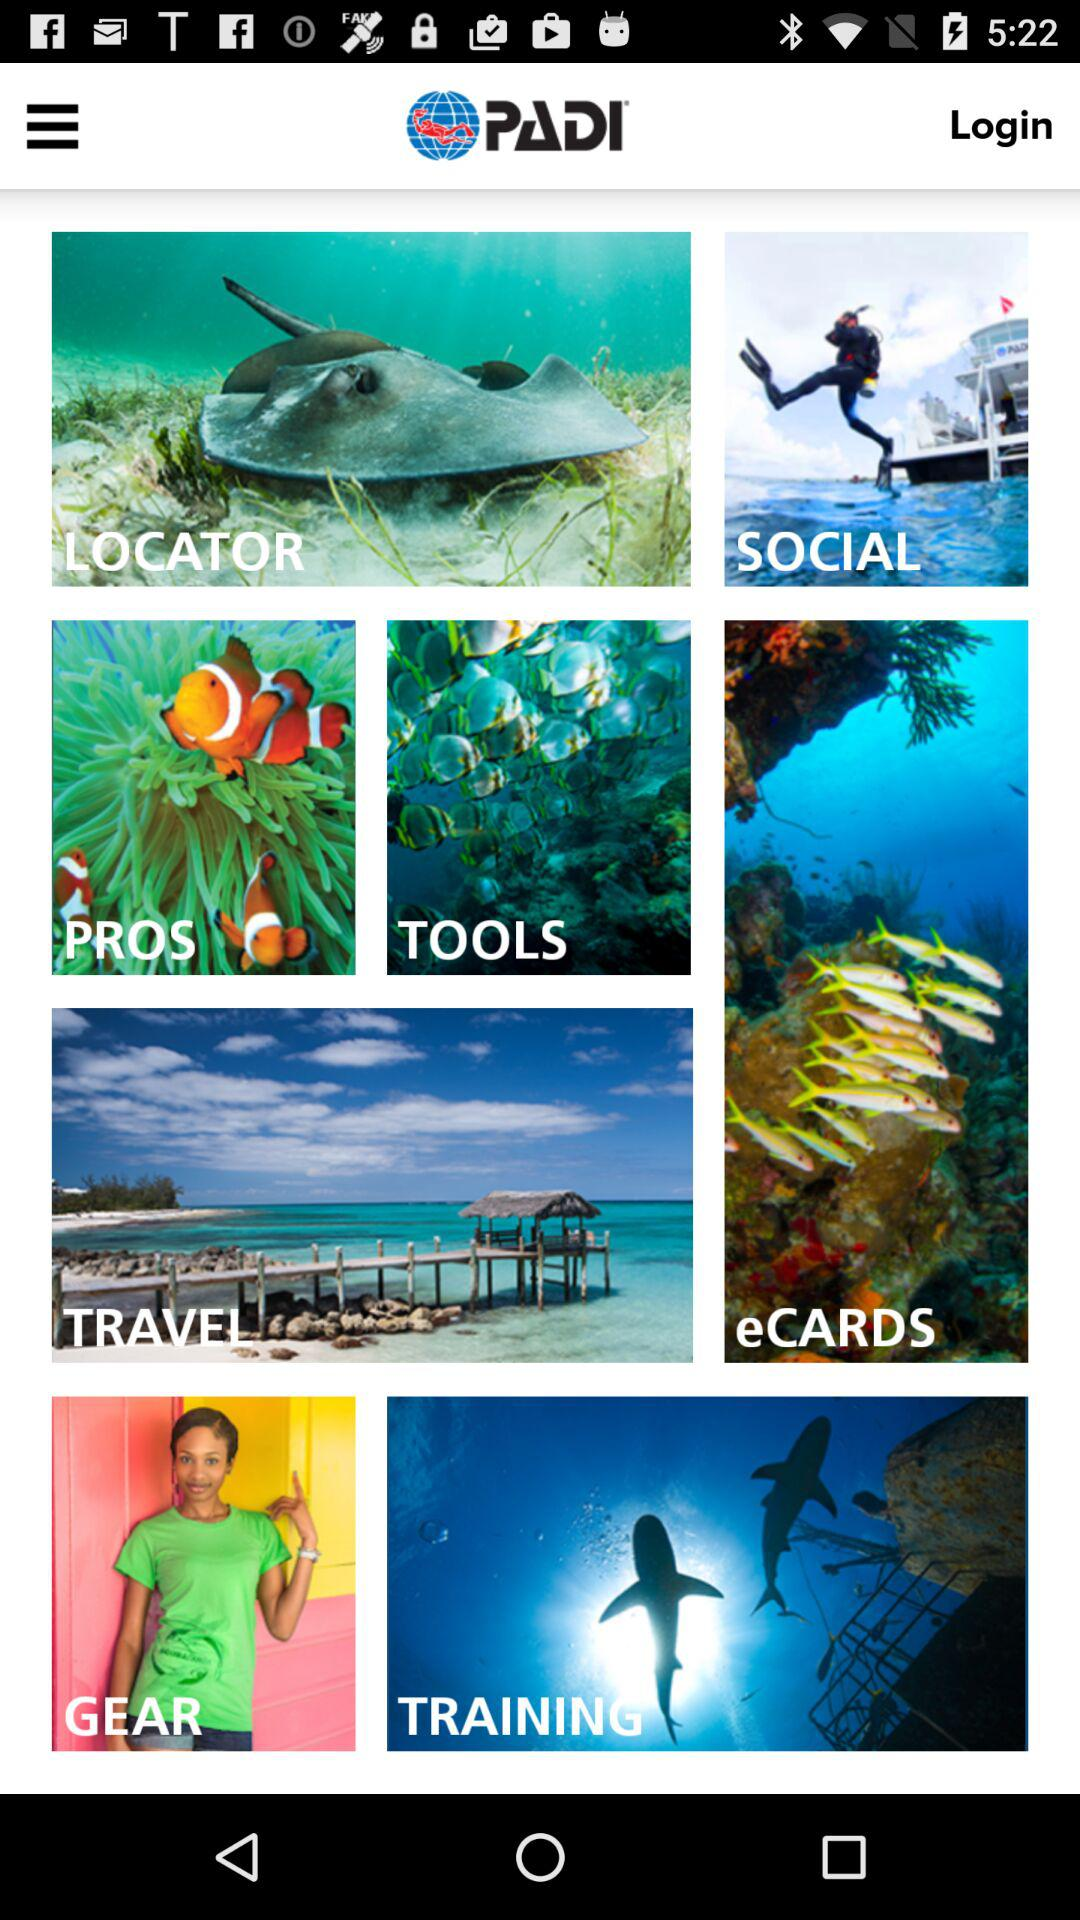What is the application name? The application name is "PADI". 